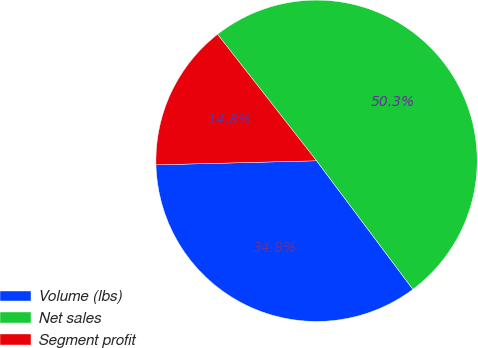<chart> <loc_0><loc_0><loc_500><loc_500><pie_chart><fcel>Volume (lbs)<fcel>Net sales<fcel>Segment profit<nl><fcel>34.83%<fcel>50.34%<fcel>14.83%<nl></chart> 